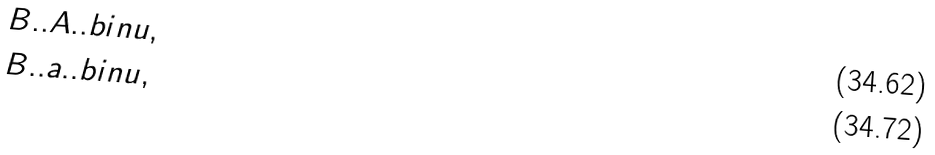<formula> <loc_0><loc_0><loc_500><loc_500>& B . . A . . b i n u , \\ & B . . a . . b i n u ,</formula> 